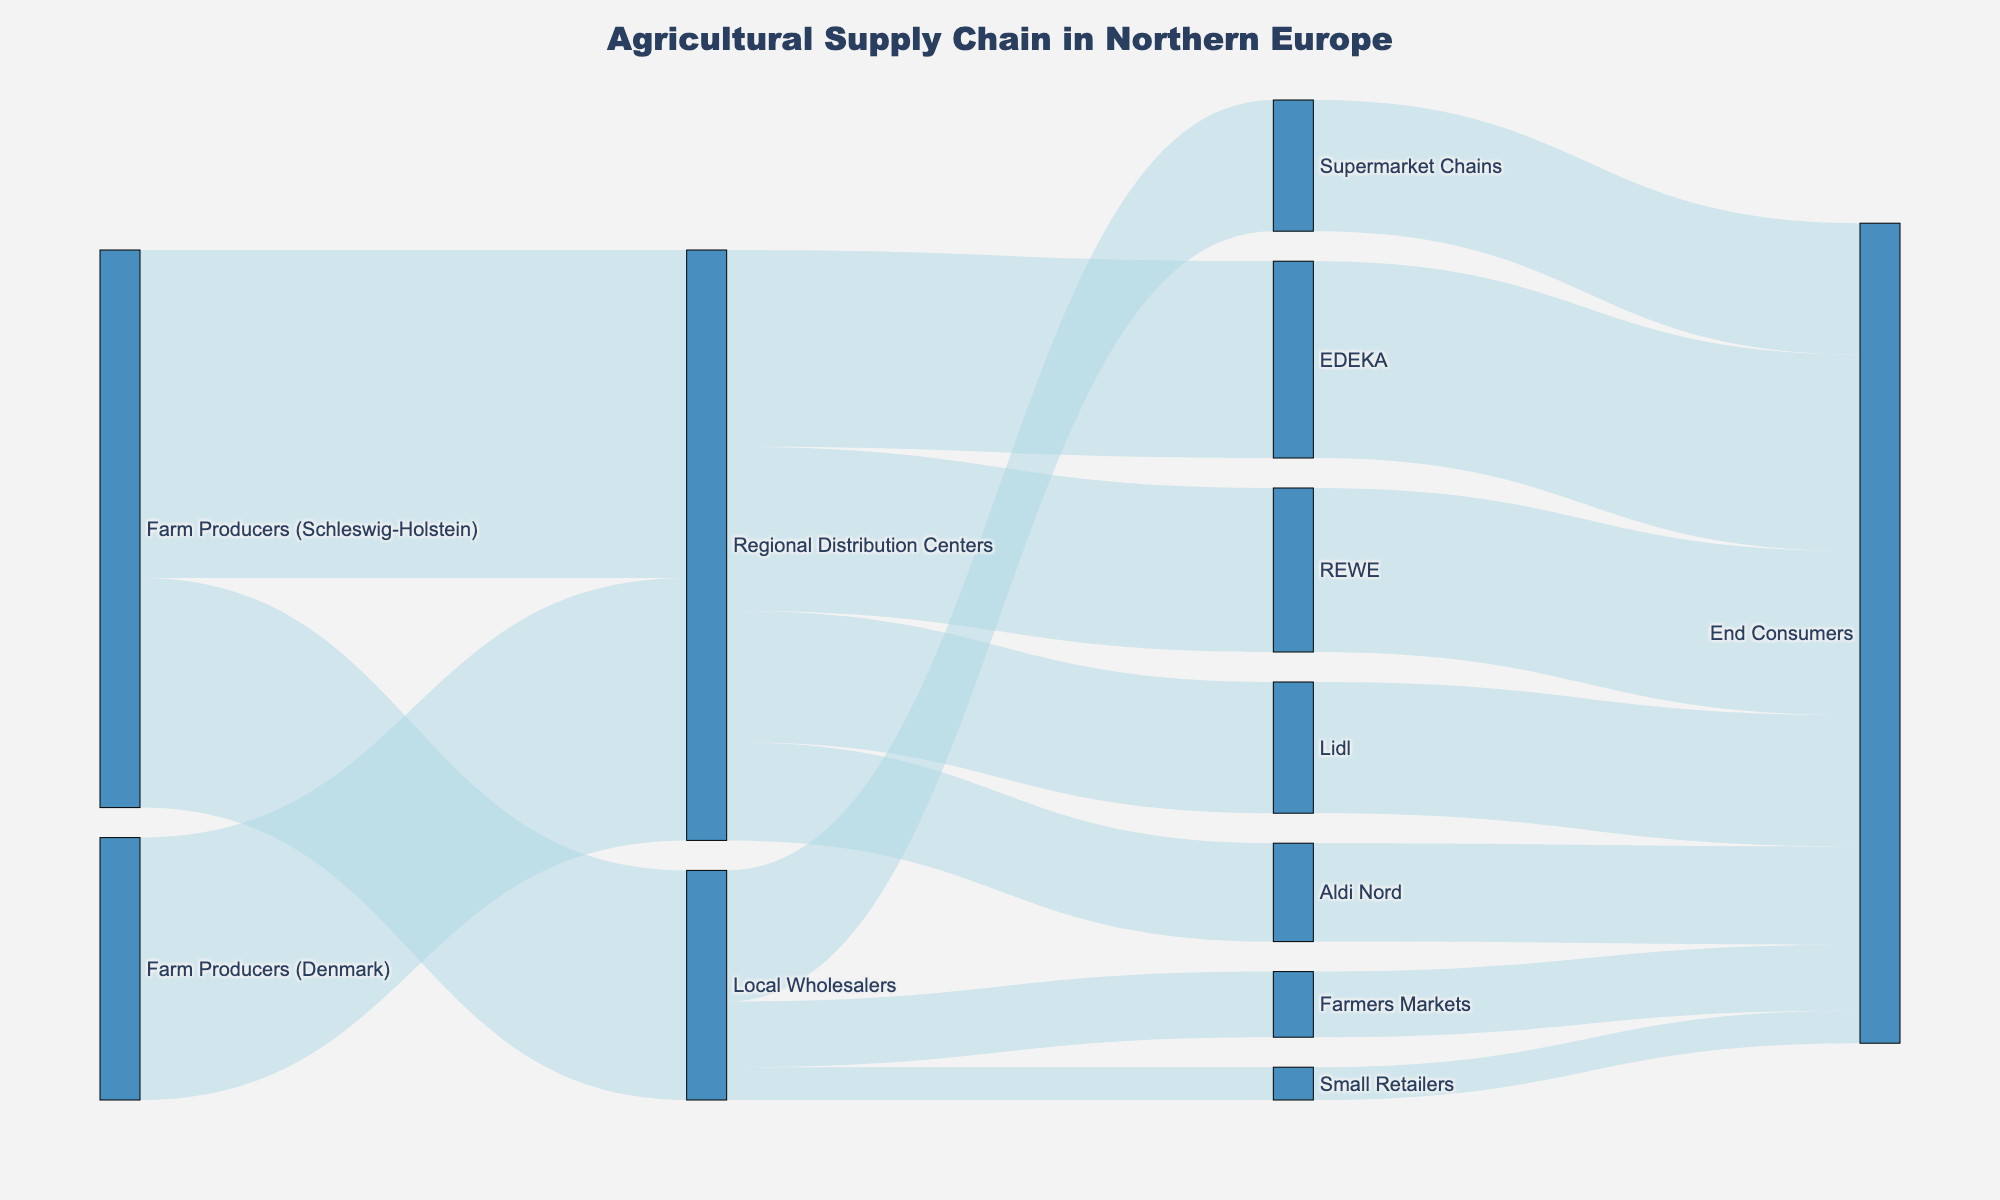What's the title of the Sankey Diagram? The diagram has a large title at the top, centered.
Answer: Agricultural Supply Chain in Northern Europe Which nodes represent the final point of consumption in the supply chain? Examining the endpoints, we see nodes where no further arrows extend. These represent the final destinations.
Answer: End Consumers How many products get distributed from Farm Producers (Schleswig-Holstein) to Regional Distribution Centers? Look at the flow labeled from Farm Producers (Schleswig-Holstein) to Regional Distribution Centers for the value.
Answer: 5000 Summing all products from the Local Wholesalers, how many go to end consumers? By following the nodes and summing their flow values: Local Wholesalers send 2000 to Supermarket Chains, 1000 to Farmers Markets, and 500 to Small Retailers. All these products go to end consumers eventually. Summing these values gives the total.
Answer: 3500 Which destination receives the least number of products from Regional Distribution Centers? Compare the values flowing from Regional Distribution Centers to EDEKA, REWE, Lidl, and Aldi Nord. The smallest value is the target with the least products.
Answer: Aldi Nord How many products go to end consumers via EDEKA? Follow the flow from Regional Distribution Centers to EDEKA and then to End Consumers. EDEKA to End Consumers arrow shows the value.
Answer: 3000 Are more products distributed from Schleswig-Holstein or Denmark to Regional Distribution Centers? Compare the values flowing from Farm Producers in Schleswig-Holstein and Denmark to the Regional Distribution Centers and add them up.
Answer: Schleswig-Holstein How many total products are handled by Regional Distribution Centers? Add up all the incoming flows to the Regional Distribution Centers from different sources: 5000 from Schleswig-Holstein and 4000 from Denmark.
Answer: 9000 Between REWE and Lidl, which receives more products from the Regional Distribution Centers? Compare the flows from Regional Distribution Centers to REWE and Lidl. The larger value indicates the recipient of more products.
Answer: REWE What is the combined total of products going to End Consumers from both the Farmers Markets and Small Retailers? Add the products flowing from Farmers Markets and Small Retailers to End Consumers. Farmers Markets send 1000 and Small Retailers send 500, so their sum is calculated.
Answer: 1500 